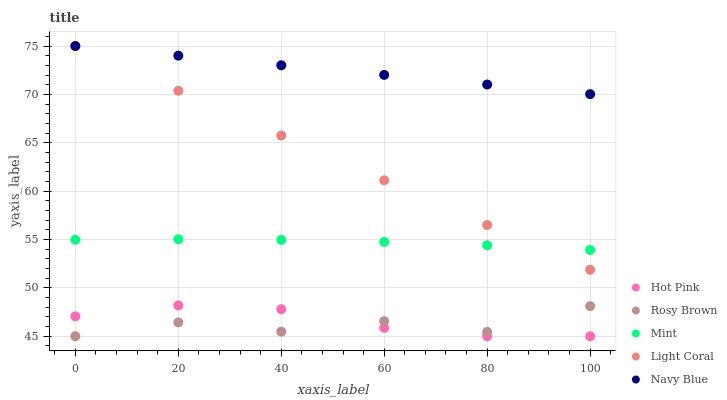Does Rosy Brown have the minimum area under the curve?
Answer yes or no. Yes. Does Navy Blue have the maximum area under the curve?
Answer yes or no. Yes. Does Navy Blue have the minimum area under the curve?
Answer yes or no. No. Does Rosy Brown have the maximum area under the curve?
Answer yes or no. No. Is Navy Blue the smoothest?
Answer yes or no. Yes. Is Rosy Brown the roughest?
Answer yes or no. Yes. Is Rosy Brown the smoothest?
Answer yes or no. No. Is Navy Blue the roughest?
Answer yes or no. No. Does Rosy Brown have the lowest value?
Answer yes or no. Yes. Does Navy Blue have the lowest value?
Answer yes or no. No. Does Navy Blue have the highest value?
Answer yes or no. Yes. Does Rosy Brown have the highest value?
Answer yes or no. No. Is Hot Pink less than Mint?
Answer yes or no. Yes. Is Light Coral greater than Hot Pink?
Answer yes or no. Yes. Does Light Coral intersect Mint?
Answer yes or no. Yes. Is Light Coral less than Mint?
Answer yes or no. No. Is Light Coral greater than Mint?
Answer yes or no. No. Does Hot Pink intersect Mint?
Answer yes or no. No. 